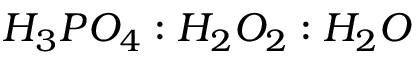Convert formula to latex. <formula><loc_0><loc_0><loc_500><loc_500>H _ { 3 } P O _ { 4 } \colon H _ { 2 } O _ { 2 } \colon H _ { 2 } O</formula> 